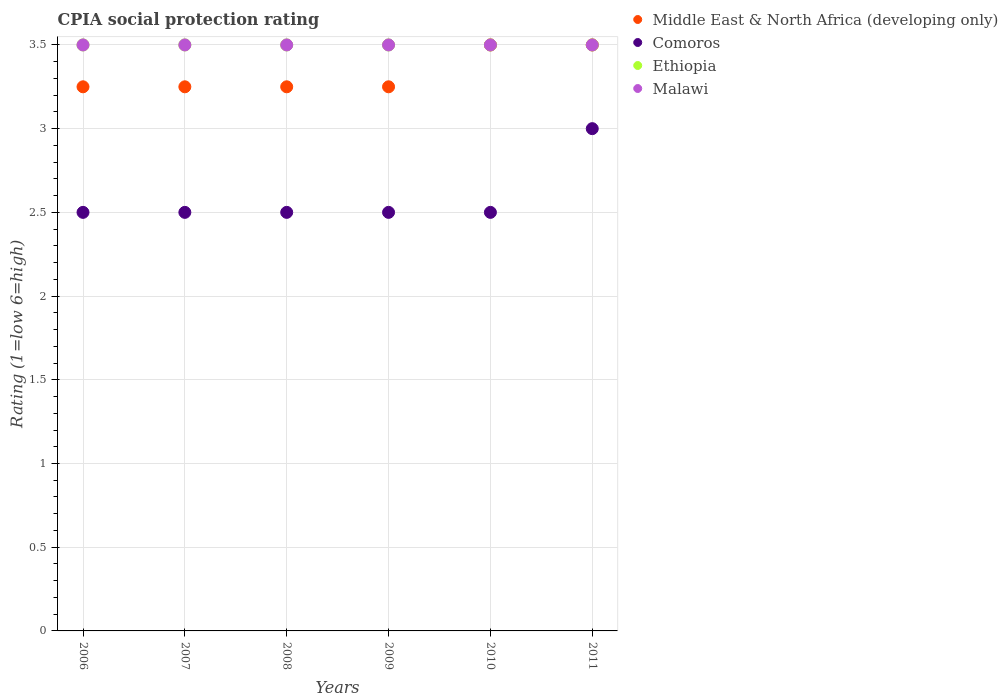How many different coloured dotlines are there?
Give a very brief answer. 4. Is the number of dotlines equal to the number of legend labels?
Give a very brief answer. Yes. What is the CPIA rating in Comoros in 2007?
Keep it short and to the point. 2.5. Across all years, what is the minimum CPIA rating in Malawi?
Your answer should be compact. 3.5. In which year was the CPIA rating in Malawi maximum?
Keep it short and to the point. 2006. In which year was the CPIA rating in Middle East & North Africa (developing only) minimum?
Offer a very short reply. 2006. What is the total CPIA rating in Comoros in the graph?
Your answer should be very brief. 15.5. What is the average CPIA rating in Malawi per year?
Ensure brevity in your answer.  3.5. What is the ratio of the CPIA rating in Malawi in 2006 to that in 2011?
Provide a succinct answer. 1. Is the difference between the CPIA rating in Ethiopia in 2006 and 2009 greater than the difference between the CPIA rating in Malawi in 2006 and 2009?
Provide a succinct answer. No. What is the difference between the highest and the lowest CPIA rating in Comoros?
Make the answer very short. 0.5. Is it the case that in every year, the sum of the CPIA rating in Malawi and CPIA rating in Ethiopia  is greater than the sum of CPIA rating in Middle East & North Africa (developing only) and CPIA rating in Comoros?
Make the answer very short. No. Is it the case that in every year, the sum of the CPIA rating in Comoros and CPIA rating in Ethiopia  is greater than the CPIA rating in Middle East & North Africa (developing only)?
Give a very brief answer. Yes. Does the CPIA rating in Middle East & North Africa (developing only) monotonically increase over the years?
Your answer should be very brief. No. Is the CPIA rating in Malawi strictly greater than the CPIA rating in Middle East & North Africa (developing only) over the years?
Offer a terse response. No. Is the CPIA rating in Ethiopia strictly less than the CPIA rating in Middle East & North Africa (developing only) over the years?
Offer a very short reply. No. How many years are there in the graph?
Give a very brief answer. 6. Are the values on the major ticks of Y-axis written in scientific E-notation?
Give a very brief answer. No. Does the graph contain any zero values?
Offer a terse response. No. Where does the legend appear in the graph?
Your answer should be very brief. Top right. How are the legend labels stacked?
Your answer should be compact. Vertical. What is the title of the graph?
Keep it short and to the point. CPIA social protection rating. What is the label or title of the X-axis?
Provide a short and direct response. Years. What is the Rating (1=low 6=high) in Middle East & North Africa (developing only) in 2007?
Give a very brief answer. 3.25. What is the Rating (1=low 6=high) in Comoros in 2007?
Make the answer very short. 2.5. What is the Rating (1=low 6=high) in Ethiopia in 2008?
Keep it short and to the point. 3.5. What is the Rating (1=low 6=high) of Malawi in 2008?
Offer a very short reply. 3.5. What is the Rating (1=low 6=high) in Middle East & North Africa (developing only) in 2009?
Keep it short and to the point. 3.25. What is the Rating (1=low 6=high) in Ethiopia in 2009?
Offer a terse response. 3.5. What is the Rating (1=low 6=high) in Malawi in 2009?
Your answer should be very brief. 3.5. What is the Rating (1=low 6=high) of Comoros in 2010?
Provide a succinct answer. 2.5. What is the Rating (1=low 6=high) in Ethiopia in 2010?
Your answer should be very brief. 3.5. What is the Rating (1=low 6=high) in Middle East & North Africa (developing only) in 2011?
Give a very brief answer. 3.5. What is the Rating (1=low 6=high) of Ethiopia in 2011?
Provide a succinct answer. 3.5. What is the Rating (1=low 6=high) in Malawi in 2011?
Ensure brevity in your answer.  3.5. Across all years, what is the maximum Rating (1=low 6=high) of Ethiopia?
Provide a short and direct response. 3.5. Across all years, what is the maximum Rating (1=low 6=high) of Malawi?
Keep it short and to the point. 3.5. Across all years, what is the minimum Rating (1=low 6=high) of Ethiopia?
Make the answer very short. 3.5. Across all years, what is the minimum Rating (1=low 6=high) of Malawi?
Offer a terse response. 3.5. What is the total Rating (1=low 6=high) in Ethiopia in the graph?
Ensure brevity in your answer.  21. What is the total Rating (1=low 6=high) of Malawi in the graph?
Ensure brevity in your answer.  21. What is the difference between the Rating (1=low 6=high) of Comoros in 2006 and that in 2007?
Ensure brevity in your answer.  0. What is the difference between the Rating (1=low 6=high) of Malawi in 2006 and that in 2008?
Your answer should be very brief. 0. What is the difference between the Rating (1=low 6=high) of Ethiopia in 2006 and that in 2009?
Give a very brief answer. 0. What is the difference between the Rating (1=low 6=high) of Middle East & North Africa (developing only) in 2006 and that in 2010?
Provide a succinct answer. -0.25. What is the difference between the Rating (1=low 6=high) of Malawi in 2006 and that in 2010?
Keep it short and to the point. 0. What is the difference between the Rating (1=low 6=high) in Comoros in 2006 and that in 2011?
Offer a very short reply. -0.5. What is the difference between the Rating (1=low 6=high) in Ethiopia in 2006 and that in 2011?
Ensure brevity in your answer.  0. What is the difference between the Rating (1=low 6=high) in Middle East & North Africa (developing only) in 2007 and that in 2008?
Offer a terse response. 0. What is the difference between the Rating (1=low 6=high) of Middle East & North Africa (developing only) in 2007 and that in 2009?
Give a very brief answer. 0. What is the difference between the Rating (1=low 6=high) in Middle East & North Africa (developing only) in 2007 and that in 2010?
Provide a short and direct response. -0.25. What is the difference between the Rating (1=low 6=high) in Comoros in 2007 and that in 2010?
Give a very brief answer. 0. What is the difference between the Rating (1=low 6=high) in Ethiopia in 2007 and that in 2010?
Provide a short and direct response. 0. What is the difference between the Rating (1=low 6=high) in Comoros in 2007 and that in 2011?
Give a very brief answer. -0.5. What is the difference between the Rating (1=low 6=high) in Ethiopia in 2007 and that in 2011?
Make the answer very short. 0. What is the difference between the Rating (1=low 6=high) in Comoros in 2008 and that in 2009?
Your response must be concise. 0. What is the difference between the Rating (1=low 6=high) of Ethiopia in 2008 and that in 2009?
Offer a terse response. 0. What is the difference between the Rating (1=low 6=high) in Malawi in 2008 and that in 2009?
Your response must be concise. 0. What is the difference between the Rating (1=low 6=high) of Middle East & North Africa (developing only) in 2008 and that in 2010?
Keep it short and to the point. -0.25. What is the difference between the Rating (1=low 6=high) in Ethiopia in 2008 and that in 2010?
Provide a short and direct response. 0. What is the difference between the Rating (1=low 6=high) in Middle East & North Africa (developing only) in 2008 and that in 2011?
Your answer should be compact. -0.25. What is the difference between the Rating (1=low 6=high) in Comoros in 2008 and that in 2011?
Your answer should be compact. -0.5. What is the difference between the Rating (1=low 6=high) of Malawi in 2008 and that in 2011?
Ensure brevity in your answer.  0. What is the difference between the Rating (1=low 6=high) of Ethiopia in 2009 and that in 2010?
Give a very brief answer. 0. What is the difference between the Rating (1=low 6=high) of Malawi in 2009 and that in 2010?
Your answer should be compact. 0. What is the difference between the Rating (1=low 6=high) in Middle East & North Africa (developing only) in 2010 and that in 2011?
Your answer should be compact. 0. What is the difference between the Rating (1=low 6=high) in Comoros in 2010 and that in 2011?
Keep it short and to the point. -0.5. What is the difference between the Rating (1=low 6=high) in Malawi in 2010 and that in 2011?
Offer a very short reply. 0. What is the difference between the Rating (1=low 6=high) of Middle East & North Africa (developing only) in 2006 and the Rating (1=low 6=high) of Comoros in 2007?
Give a very brief answer. 0.75. What is the difference between the Rating (1=low 6=high) in Middle East & North Africa (developing only) in 2006 and the Rating (1=low 6=high) in Ethiopia in 2007?
Give a very brief answer. -0.25. What is the difference between the Rating (1=low 6=high) of Middle East & North Africa (developing only) in 2006 and the Rating (1=low 6=high) of Malawi in 2007?
Keep it short and to the point. -0.25. What is the difference between the Rating (1=low 6=high) of Comoros in 2006 and the Rating (1=low 6=high) of Malawi in 2007?
Make the answer very short. -1. What is the difference between the Rating (1=low 6=high) in Ethiopia in 2006 and the Rating (1=low 6=high) in Malawi in 2007?
Provide a short and direct response. 0. What is the difference between the Rating (1=low 6=high) of Middle East & North Africa (developing only) in 2006 and the Rating (1=low 6=high) of Comoros in 2008?
Make the answer very short. 0.75. What is the difference between the Rating (1=low 6=high) in Middle East & North Africa (developing only) in 2006 and the Rating (1=low 6=high) in Ethiopia in 2008?
Give a very brief answer. -0.25. What is the difference between the Rating (1=low 6=high) in Middle East & North Africa (developing only) in 2006 and the Rating (1=low 6=high) in Malawi in 2008?
Keep it short and to the point. -0.25. What is the difference between the Rating (1=low 6=high) of Comoros in 2006 and the Rating (1=low 6=high) of Ethiopia in 2008?
Make the answer very short. -1. What is the difference between the Rating (1=low 6=high) in Middle East & North Africa (developing only) in 2006 and the Rating (1=low 6=high) in Comoros in 2009?
Ensure brevity in your answer.  0.75. What is the difference between the Rating (1=low 6=high) of Middle East & North Africa (developing only) in 2006 and the Rating (1=low 6=high) of Malawi in 2009?
Your response must be concise. -0.25. What is the difference between the Rating (1=low 6=high) in Middle East & North Africa (developing only) in 2006 and the Rating (1=low 6=high) in Comoros in 2010?
Keep it short and to the point. 0.75. What is the difference between the Rating (1=low 6=high) in Middle East & North Africa (developing only) in 2006 and the Rating (1=low 6=high) in Ethiopia in 2010?
Provide a succinct answer. -0.25. What is the difference between the Rating (1=low 6=high) of Middle East & North Africa (developing only) in 2006 and the Rating (1=low 6=high) of Malawi in 2010?
Your response must be concise. -0.25. What is the difference between the Rating (1=low 6=high) in Comoros in 2006 and the Rating (1=low 6=high) in Malawi in 2010?
Your answer should be very brief. -1. What is the difference between the Rating (1=low 6=high) in Ethiopia in 2006 and the Rating (1=low 6=high) in Malawi in 2010?
Your response must be concise. 0. What is the difference between the Rating (1=low 6=high) of Middle East & North Africa (developing only) in 2006 and the Rating (1=low 6=high) of Malawi in 2011?
Keep it short and to the point. -0.25. What is the difference between the Rating (1=low 6=high) of Comoros in 2006 and the Rating (1=low 6=high) of Ethiopia in 2011?
Offer a very short reply. -1. What is the difference between the Rating (1=low 6=high) in Middle East & North Africa (developing only) in 2007 and the Rating (1=low 6=high) in Ethiopia in 2008?
Ensure brevity in your answer.  -0.25. What is the difference between the Rating (1=low 6=high) of Middle East & North Africa (developing only) in 2007 and the Rating (1=low 6=high) of Malawi in 2008?
Offer a terse response. -0.25. What is the difference between the Rating (1=low 6=high) of Comoros in 2007 and the Rating (1=low 6=high) of Ethiopia in 2008?
Your answer should be compact. -1. What is the difference between the Rating (1=low 6=high) of Ethiopia in 2007 and the Rating (1=low 6=high) of Malawi in 2008?
Ensure brevity in your answer.  0. What is the difference between the Rating (1=low 6=high) in Middle East & North Africa (developing only) in 2007 and the Rating (1=low 6=high) in Ethiopia in 2009?
Offer a terse response. -0.25. What is the difference between the Rating (1=low 6=high) of Comoros in 2007 and the Rating (1=low 6=high) of Ethiopia in 2009?
Your answer should be compact. -1. What is the difference between the Rating (1=low 6=high) of Comoros in 2007 and the Rating (1=low 6=high) of Malawi in 2009?
Your answer should be very brief. -1. What is the difference between the Rating (1=low 6=high) in Ethiopia in 2007 and the Rating (1=low 6=high) in Malawi in 2009?
Offer a terse response. 0. What is the difference between the Rating (1=low 6=high) in Middle East & North Africa (developing only) in 2007 and the Rating (1=low 6=high) in Malawi in 2010?
Ensure brevity in your answer.  -0.25. What is the difference between the Rating (1=low 6=high) in Middle East & North Africa (developing only) in 2007 and the Rating (1=low 6=high) in Comoros in 2011?
Ensure brevity in your answer.  0.25. What is the difference between the Rating (1=low 6=high) of Comoros in 2007 and the Rating (1=low 6=high) of Malawi in 2011?
Give a very brief answer. -1. What is the difference between the Rating (1=low 6=high) in Ethiopia in 2007 and the Rating (1=low 6=high) in Malawi in 2011?
Your response must be concise. 0. What is the difference between the Rating (1=low 6=high) of Comoros in 2008 and the Rating (1=low 6=high) of Ethiopia in 2009?
Provide a succinct answer. -1. What is the difference between the Rating (1=low 6=high) in Middle East & North Africa (developing only) in 2008 and the Rating (1=low 6=high) in Comoros in 2010?
Your answer should be compact. 0.75. What is the difference between the Rating (1=low 6=high) of Middle East & North Africa (developing only) in 2008 and the Rating (1=low 6=high) of Malawi in 2010?
Your answer should be compact. -0.25. What is the difference between the Rating (1=low 6=high) of Comoros in 2008 and the Rating (1=low 6=high) of Malawi in 2010?
Ensure brevity in your answer.  -1. What is the difference between the Rating (1=low 6=high) of Ethiopia in 2008 and the Rating (1=low 6=high) of Malawi in 2010?
Your answer should be compact. 0. What is the difference between the Rating (1=low 6=high) in Middle East & North Africa (developing only) in 2008 and the Rating (1=low 6=high) in Malawi in 2011?
Offer a very short reply. -0.25. What is the difference between the Rating (1=low 6=high) in Ethiopia in 2008 and the Rating (1=low 6=high) in Malawi in 2011?
Keep it short and to the point. 0. What is the difference between the Rating (1=low 6=high) of Middle East & North Africa (developing only) in 2009 and the Rating (1=low 6=high) of Ethiopia in 2010?
Make the answer very short. -0.25. What is the difference between the Rating (1=low 6=high) in Middle East & North Africa (developing only) in 2009 and the Rating (1=low 6=high) in Malawi in 2010?
Provide a succinct answer. -0.25. What is the difference between the Rating (1=low 6=high) of Ethiopia in 2009 and the Rating (1=low 6=high) of Malawi in 2010?
Give a very brief answer. 0. What is the difference between the Rating (1=low 6=high) of Middle East & North Africa (developing only) in 2009 and the Rating (1=low 6=high) of Malawi in 2011?
Keep it short and to the point. -0.25. What is the difference between the Rating (1=low 6=high) of Comoros in 2009 and the Rating (1=low 6=high) of Ethiopia in 2011?
Your answer should be very brief. -1. What is the difference between the Rating (1=low 6=high) of Middle East & North Africa (developing only) in 2010 and the Rating (1=low 6=high) of Comoros in 2011?
Give a very brief answer. 0.5. What is the average Rating (1=low 6=high) of Comoros per year?
Keep it short and to the point. 2.58. What is the average Rating (1=low 6=high) in Ethiopia per year?
Your response must be concise. 3.5. What is the average Rating (1=low 6=high) in Malawi per year?
Make the answer very short. 3.5. In the year 2006, what is the difference between the Rating (1=low 6=high) in Middle East & North Africa (developing only) and Rating (1=low 6=high) in Malawi?
Your response must be concise. -0.25. In the year 2006, what is the difference between the Rating (1=low 6=high) in Comoros and Rating (1=low 6=high) in Ethiopia?
Give a very brief answer. -1. In the year 2007, what is the difference between the Rating (1=low 6=high) of Middle East & North Africa (developing only) and Rating (1=low 6=high) of Ethiopia?
Your response must be concise. -0.25. In the year 2007, what is the difference between the Rating (1=low 6=high) in Ethiopia and Rating (1=low 6=high) in Malawi?
Give a very brief answer. 0. In the year 2008, what is the difference between the Rating (1=low 6=high) of Middle East & North Africa (developing only) and Rating (1=low 6=high) of Ethiopia?
Keep it short and to the point. -0.25. In the year 2008, what is the difference between the Rating (1=low 6=high) of Middle East & North Africa (developing only) and Rating (1=low 6=high) of Malawi?
Keep it short and to the point. -0.25. In the year 2009, what is the difference between the Rating (1=low 6=high) of Comoros and Rating (1=low 6=high) of Malawi?
Provide a succinct answer. -1. In the year 2009, what is the difference between the Rating (1=low 6=high) of Ethiopia and Rating (1=low 6=high) of Malawi?
Keep it short and to the point. 0. In the year 2010, what is the difference between the Rating (1=low 6=high) of Middle East & North Africa (developing only) and Rating (1=low 6=high) of Ethiopia?
Provide a short and direct response. 0. In the year 2010, what is the difference between the Rating (1=low 6=high) in Middle East & North Africa (developing only) and Rating (1=low 6=high) in Malawi?
Your answer should be very brief. 0. In the year 2010, what is the difference between the Rating (1=low 6=high) of Comoros and Rating (1=low 6=high) of Malawi?
Make the answer very short. -1. In the year 2010, what is the difference between the Rating (1=low 6=high) in Ethiopia and Rating (1=low 6=high) in Malawi?
Ensure brevity in your answer.  0. In the year 2011, what is the difference between the Rating (1=low 6=high) of Middle East & North Africa (developing only) and Rating (1=low 6=high) of Malawi?
Ensure brevity in your answer.  0. In the year 2011, what is the difference between the Rating (1=low 6=high) in Comoros and Rating (1=low 6=high) in Ethiopia?
Your answer should be very brief. -0.5. In the year 2011, what is the difference between the Rating (1=low 6=high) in Comoros and Rating (1=low 6=high) in Malawi?
Keep it short and to the point. -0.5. In the year 2011, what is the difference between the Rating (1=low 6=high) in Ethiopia and Rating (1=low 6=high) in Malawi?
Provide a succinct answer. 0. What is the ratio of the Rating (1=low 6=high) of Comoros in 2006 to that in 2007?
Keep it short and to the point. 1. What is the ratio of the Rating (1=low 6=high) of Ethiopia in 2006 to that in 2007?
Provide a short and direct response. 1. What is the ratio of the Rating (1=low 6=high) of Malawi in 2006 to that in 2007?
Provide a short and direct response. 1. What is the ratio of the Rating (1=low 6=high) of Comoros in 2006 to that in 2008?
Your answer should be very brief. 1. What is the ratio of the Rating (1=low 6=high) in Malawi in 2006 to that in 2008?
Provide a short and direct response. 1. What is the ratio of the Rating (1=low 6=high) in Ethiopia in 2006 to that in 2009?
Provide a short and direct response. 1. What is the ratio of the Rating (1=low 6=high) in Middle East & North Africa (developing only) in 2006 to that in 2010?
Your response must be concise. 0.93. What is the ratio of the Rating (1=low 6=high) of Comoros in 2006 to that in 2010?
Keep it short and to the point. 1. What is the ratio of the Rating (1=low 6=high) of Ethiopia in 2006 to that in 2010?
Offer a very short reply. 1. What is the ratio of the Rating (1=low 6=high) of Comoros in 2007 to that in 2008?
Provide a short and direct response. 1. What is the ratio of the Rating (1=low 6=high) of Ethiopia in 2007 to that in 2008?
Ensure brevity in your answer.  1. What is the ratio of the Rating (1=low 6=high) of Middle East & North Africa (developing only) in 2007 to that in 2009?
Your response must be concise. 1. What is the ratio of the Rating (1=low 6=high) of Ethiopia in 2007 to that in 2009?
Your answer should be compact. 1. What is the ratio of the Rating (1=low 6=high) in Malawi in 2007 to that in 2009?
Provide a short and direct response. 1. What is the ratio of the Rating (1=low 6=high) in Middle East & North Africa (developing only) in 2007 to that in 2010?
Give a very brief answer. 0.93. What is the ratio of the Rating (1=low 6=high) of Comoros in 2007 to that in 2010?
Your answer should be compact. 1. What is the ratio of the Rating (1=low 6=high) of Middle East & North Africa (developing only) in 2007 to that in 2011?
Your answer should be compact. 0.93. What is the ratio of the Rating (1=low 6=high) in Comoros in 2007 to that in 2011?
Provide a succinct answer. 0.83. What is the ratio of the Rating (1=low 6=high) in Ethiopia in 2007 to that in 2011?
Give a very brief answer. 1. What is the ratio of the Rating (1=low 6=high) of Malawi in 2007 to that in 2011?
Provide a short and direct response. 1. What is the ratio of the Rating (1=low 6=high) in Middle East & North Africa (developing only) in 2008 to that in 2009?
Offer a terse response. 1. What is the ratio of the Rating (1=low 6=high) in Ethiopia in 2008 to that in 2009?
Provide a succinct answer. 1. What is the ratio of the Rating (1=low 6=high) in Malawi in 2008 to that in 2009?
Give a very brief answer. 1. What is the ratio of the Rating (1=low 6=high) of Ethiopia in 2008 to that in 2010?
Your response must be concise. 1. What is the ratio of the Rating (1=low 6=high) in Malawi in 2008 to that in 2010?
Your answer should be compact. 1. What is the ratio of the Rating (1=low 6=high) in Comoros in 2008 to that in 2011?
Your answer should be very brief. 0.83. What is the ratio of the Rating (1=low 6=high) in Ethiopia in 2008 to that in 2011?
Give a very brief answer. 1. What is the ratio of the Rating (1=low 6=high) of Malawi in 2008 to that in 2011?
Make the answer very short. 1. What is the ratio of the Rating (1=low 6=high) in Ethiopia in 2009 to that in 2010?
Make the answer very short. 1. What is the ratio of the Rating (1=low 6=high) in Middle East & North Africa (developing only) in 2009 to that in 2011?
Your response must be concise. 0.93. What is the ratio of the Rating (1=low 6=high) of Comoros in 2009 to that in 2011?
Provide a short and direct response. 0.83. What is the ratio of the Rating (1=low 6=high) of Ethiopia in 2009 to that in 2011?
Give a very brief answer. 1. What is the ratio of the Rating (1=low 6=high) in Middle East & North Africa (developing only) in 2010 to that in 2011?
Your answer should be very brief. 1. What is the ratio of the Rating (1=low 6=high) in Ethiopia in 2010 to that in 2011?
Keep it short and to the point. 1. What is the difference between the highest and the second highest Rating (1=low 6=high) of Ethiopia?
Give a very brief answer. 0. What is the difference between the highest and the lowest Rating (1=low 6=high) of Comoros?
Give a very brief answer. 0.5. 